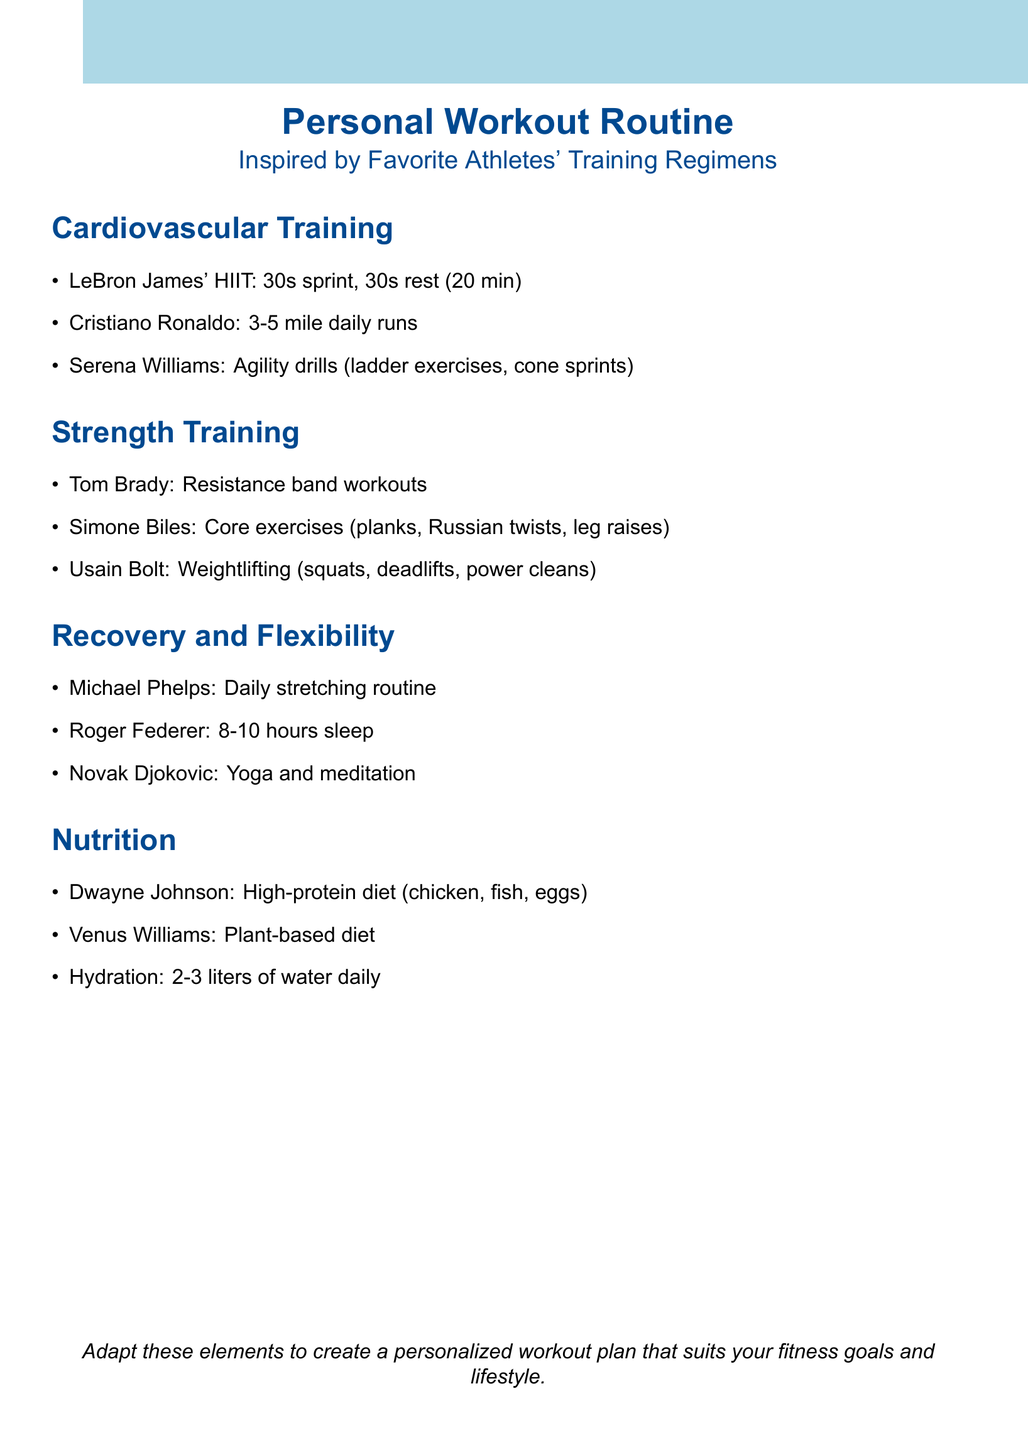What type of cardiovascular training does LeBron James do? The document states that LeBron James performs high-intensity interval training (HIIT) on the treadmill.
Answer: HIIT How many hours of sleep does Roger Federer emphasize for recovery? The document mentions that Roger Federer emphasizes proper sleep for recovery, specifically stating the amount of time.
Answer: 8-10 hours What is Serena Williams' focus in her training regimen? The document lists agility drills as a significant part of Serena Williams' training routine.
Answer: Agility drills What kind of diet does Dwayne 'The Rock' Johnson follow? The document describes Dwayne Johnson's diet as high-protein, emphasizing certain food types.
Answer: High-protein diet Which athlete's routine includes yoga and meditation? The document identifies Novak Djokovic as using yoga and meditation for mental and physical balance.
Answer: Novak Djokovic Why is hydration emphasized in the document? The document stresses the importance of hydration with a specific daily water intake recommendation for athletes.
Answer: At least 2-3 liters of water daily Which strength-training exercise is associated with Usain Bolt? The document lists specific exercises in Usain Bolt's weightlifting routine.
Answer: Squats, deadlifts, power cleans What is the main conclusion of the document? The document concludes by encouraging the adaptation of various elements from athletes' routines into a personalized workout plan.
Answer: Personalized workout plan 